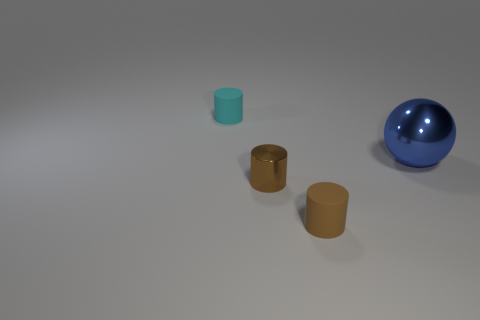What number of other things are there of the same shape as the blue thing?
Your answer should be very brief. 0. What number of objects are small cyan matte objects behind the tiny shiny cylinder or small rubber cylinders right of the tiny cyan cylinder?
Your response must be concise. 2. There is a thing that is both behind the shiny cylinder and left of the ball; how big is it?
Your answer should be very brief. Small. Is the shape of the shiny thing that is left of the large thing the same as  the blue object?
Give a very brief answer. No. What size is the brown cylinder that is right of the small shiny cylinder that is to the right of the small thing that is behind the large object?
Keep it short and to the point. Small. There is a rubber object that is the same color as the metallic cylinder; what is its size?
Make the answer very short. Small. What number of objects are either balls or small things?
Make the answer very short. 4. The object that is on the right side of the tiny shiny cylinder and behind the brown matte cylinder has what shape?
Your answer should be very brief. Sphere. There is a brown metal thing; does it have the same shape as the rubber thing that is behind the blue metal sphere?
Your answer should be very brief. Yes. There is a small metal cylinder; are there any big things on the left side of it?
Your response must be concise. No. 